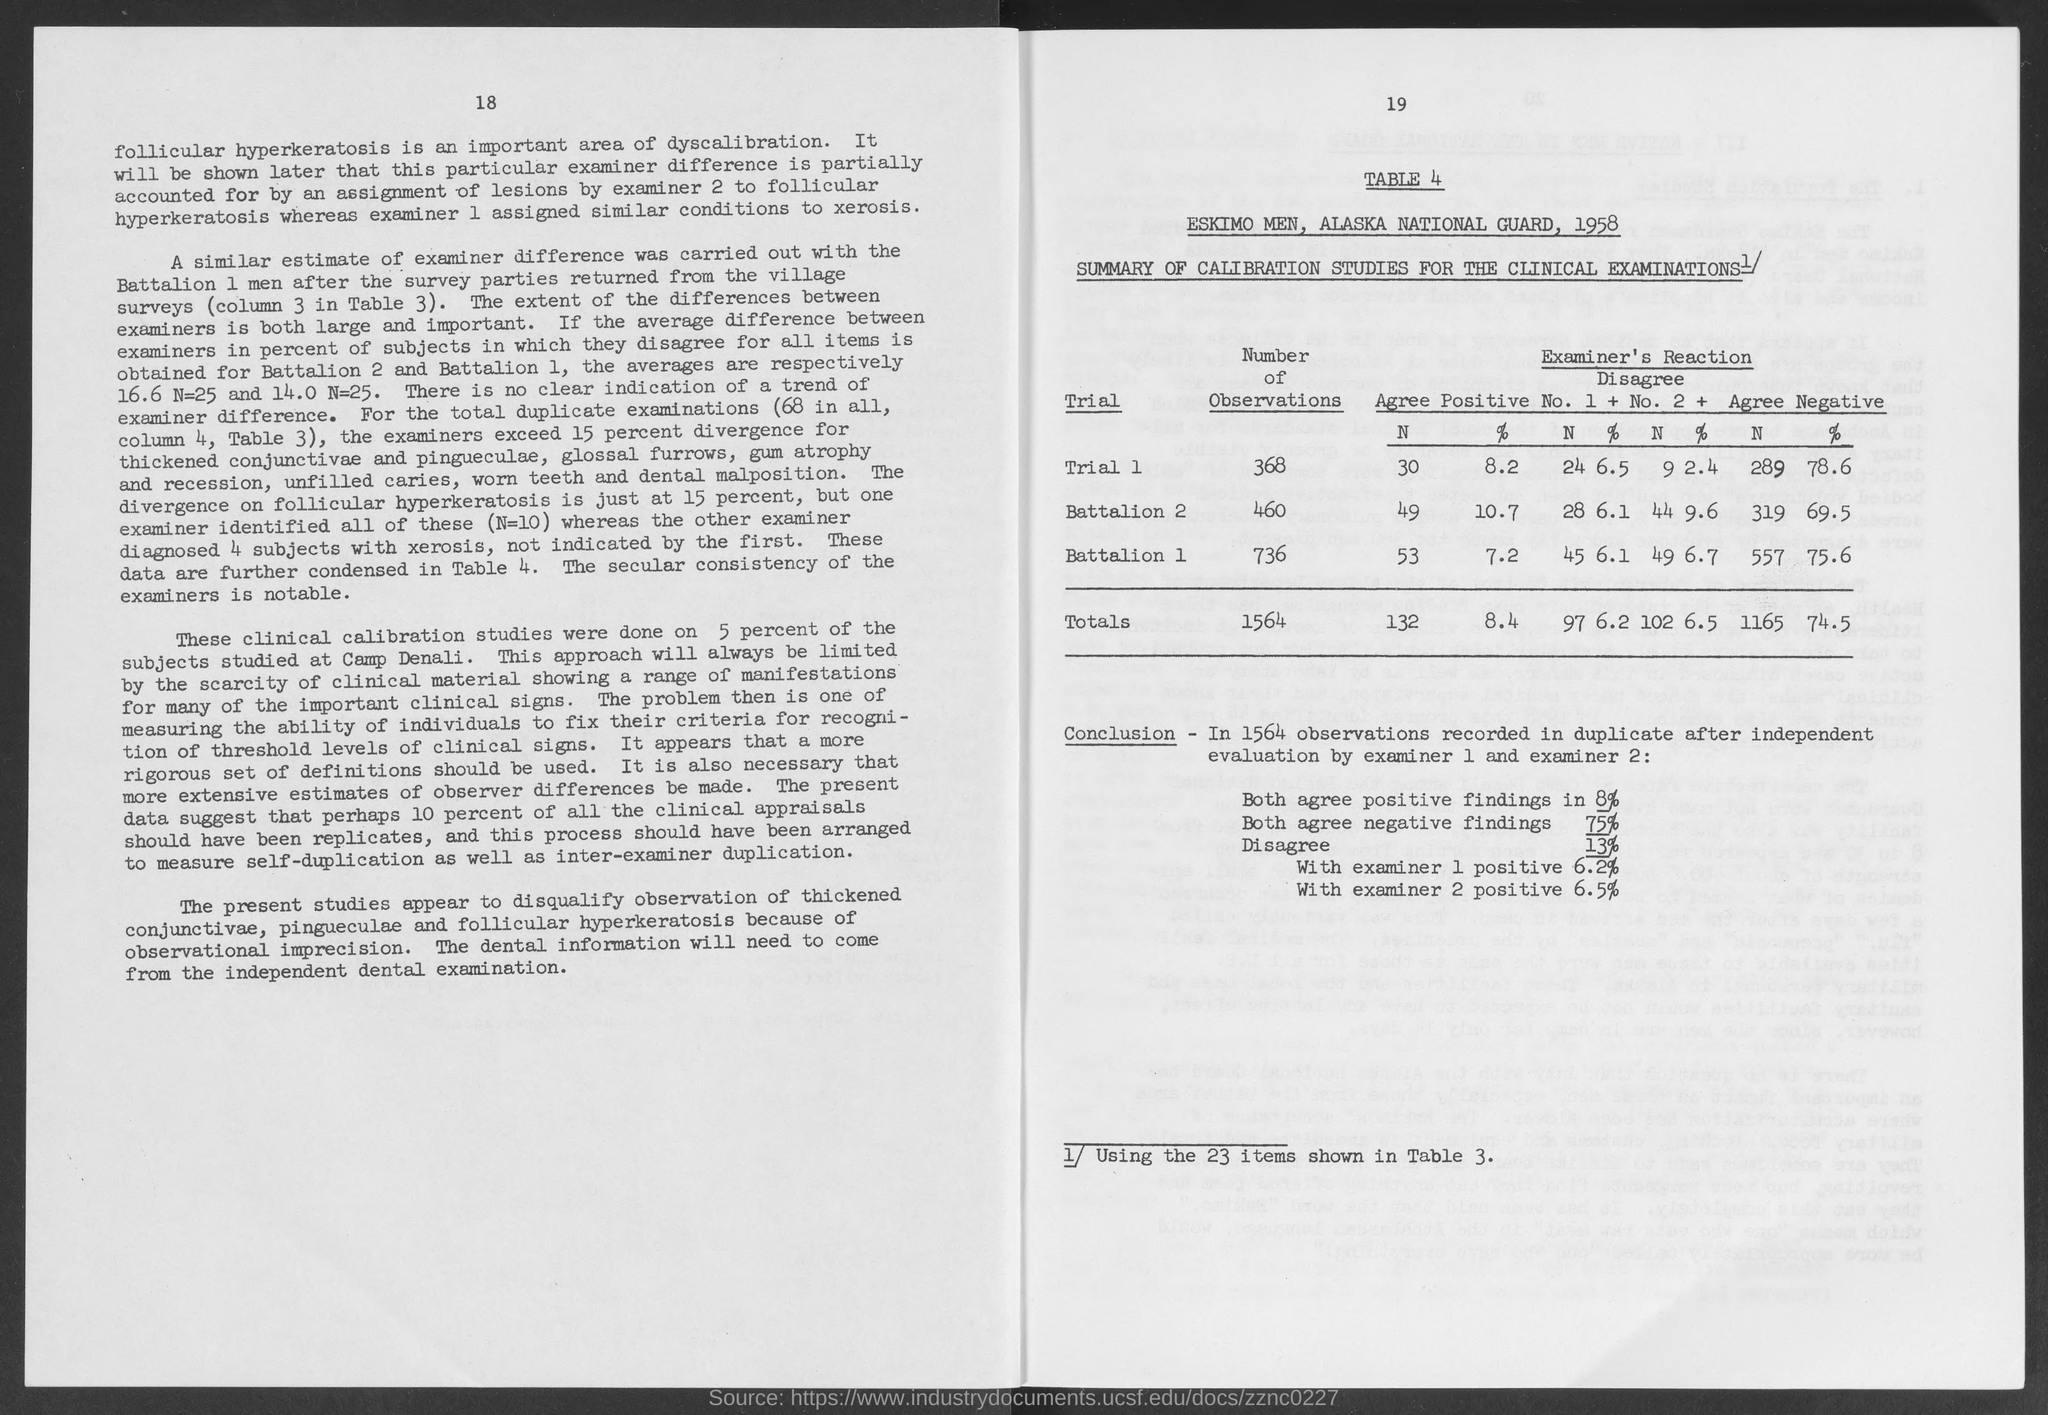What is the table number?
Your answer should be very brief. Table 4. What is the number of observations in trial 1?
Provide a short and direct response. 368. What is the total number of observations?
Ensure brevity in your answer.  1564. What is the number of observations in battalion 1?
Offer a very short reply. 736. What is the number of observations in battalion 2?
Keep it short and to the point. 460. 